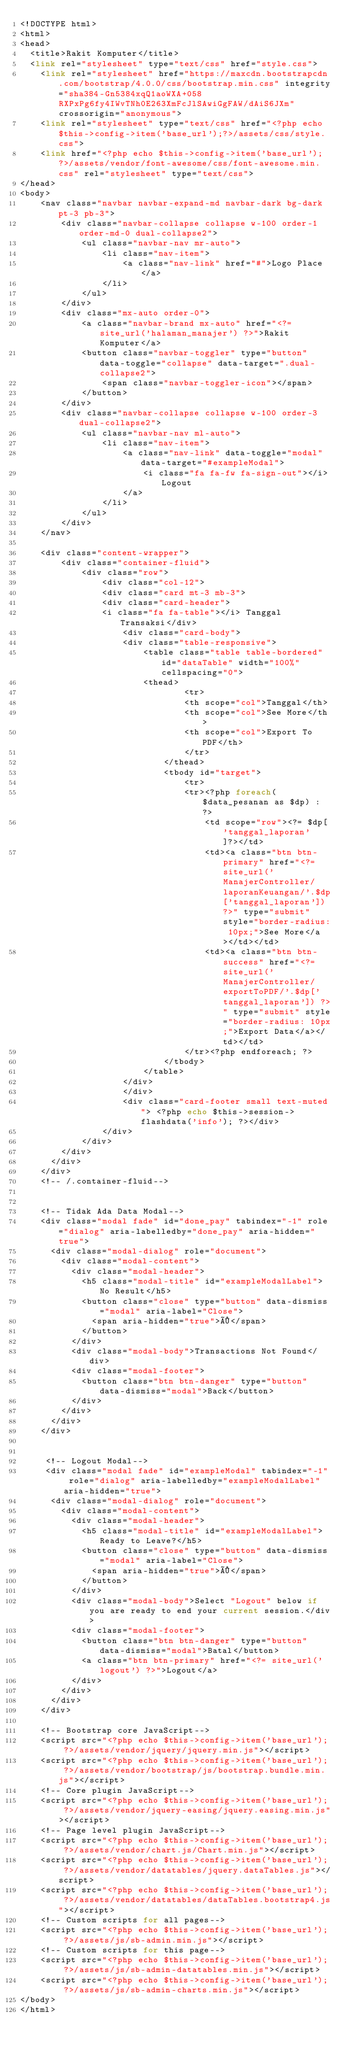<code> <loc_0><loc_0><loc_500><loc_500><_PHP_><!DOCTYPE html>
<html>
<head>
	<title>Rakit Komputer</title>
	<link rel="stylesheet" type="text/css" href="style.css">
    <link rel="stylesheet" href="https://maxcdn.bootstrapcdn.com/bootstrap/4.0.0/css/bootstrap.min.css" integrity="sha384-Gn5384xqQ1aoWXA+058RXPxPg6fy4IWvTNh0E263XmFcJlSAwiGgFAW/dAiS6JXm" crossorigin="anonymous">
    <link rel="stylesheet" type="text/css" href="<?php echo $this->config->item('base_url');?>/assets/css/style.css">
    <link href="<?php echo $this->config->item('base_url'); ?>/assets/vendor/font-awesome/css/font-awesome.min.css" rel="stylesheet" type="text/css">
</head>
<body>
    <nav class="navbar navbar-expand-md navbar-dark bg-dark pt-3 pb-3">
        <div class="navbar-collapse collapse w-100 order-1 order-md-0 dual-collapse2">
            <ul class="navbar-nav mr-auto">
                <li class="nav-item">    
                    <a class="nav-link" href="#">Logo Place </a>
                </li>
            </ul>
        </div>
        <div class="mx-auto order-0">
            <a class="navbar-brand mx-auto" href="<?= site_url('halaman_manajer') ?>">Rakit Komputer</a>
            <button class="navbar-toggler" type="button" data-toggle="collapse" data-target=".dual-collapse2">
                <span class="navbar-toggler-icon"></span>
            </button>
        </div>
        <div class="navbar-collapse collapse w-100 order-3 dual-collapse2">
            <ul class="navbar-nav ml-auto">
                <li class="nav-item">
                    <a class="nav-link" data-toggle="modal" data-target="#exampleModal">
                        <i class="fa fa-fw fa-sign-out"></i>Logout
                    </a>
                </li>
            </ul>
        </div>
    </nav>

    <div class="content-wrapper">
        <div class="container-fluid">
            <div class="row">
                <div class="col-12">
                <div class="card mt-3 mb-3">
                <div class="card-header">
                <i class="fa fa-table"></i> Tanggal Transaksi</div>
                    <div class="card-body">
                    <div class="table-responsive">
                        <table class="table table-bordered" id="dataTable" width="100%" cellspacing="0">
                        <thead>
                                <tr>
                                <th scope="col">Tanggal</th>
                                <th scope="col">See More</th>
                                <th scope="col">Export To PDF</th>
                                </tr>
                            </thead>
                            <tbody id="target">
                                <tr>
                                <tr><?php foreach($data_pesanan as $dp) : ?>
                                    <td scope="row"><?= $dp['tanggal_laporan']?></td>
                                    <td><a class="btn btn-primary" href="<?= site_url('ManajerController/laporanKeuangan/'.$dp['tanggal_laporan']) ?>" type="submit" style="border-radius: 10px;">See More</a></td></td>
                                    <td><a class="btn btn-success" href="<?= site_url('ManajerController/exportToPDF/'.$dp['tanggal_laporan']) ?>" type="submit" style="border-radius: 10px;">Export Data</a></td></td>
                                </tr><?php endforeach; ?>
                            </tbody>                   
                        </table>
                    </div>
                    </div>
                    <div class="card-footer small text-muted"> <?php echo $this->session->flashdata('info'); ?></div>
                </div>
            </div>
        </div>
      </div>
    </div>
    <!-- /.container-fluid-->


    <!-- Tidak Ada Data Modal-->
    <div class="modal fade" id="done_pay" tabindex="-1" role="dialog" aria-labelledby="done_pay" aria-hidden="true">
      <div class="modal-dialog" role="document">
        <div class="modal-content">
          <div class="modal-header">
            <h5 class="modal-title" id="exampleModalLabel">No Result</h5>
            <button class="close" type="button" data-dismiss="modal" aria-label="Close">
              <span aria-hidden="true">×</span>
            </button>
          </div>
          <div class="modal-body">Transactions Not Found</div>
          <div class="modal-footer">
            <button class="btn btn-danger" type="button" data-dismiss="modal">Back</button>
          </div>
        </div>
      </div>
    </div>


     <!-- Logout Modal-->
     <div class="modal fade" id="exampleModal" tabindex="-1" role="dialog" aria-labelledby="exampleModalLabel" aria-hidden="true">
      <div class="modal-dialog" role="document">
        <div class="modal-content">
          <div class="modal-header">
            <h5 class="modal-title" id="exampleModalLabel">Ready to Leave?</h5>
            <button class="close" type="button" data-dismiss="modal" aria-label="Close">
              <span aria-hidden="true">×</span>
            </button>
          </div>
          <div class="modal-body">Select "Logout" below if you are ready to end your current session.</div>
          <div class="modal-footer">
            <button class="btn btn-danger" type="button" data-dismiss="modal">Batal</button>
            <a class="btn btn-primary" href="<?= site_url('logout') ?>">Logout</a>
          </div>
        </div>
      </div>
    </div>

    <!-- Bootstrap core JavaScript-->
    <script src="<?php echo $this->config->item('base_url'); ?>/assets/vendor/jquery/jquery.min.js"></script>
    <script src="<?php echo $this->config->item('base_url'); ?>/assets/vendor/bootstrap/js/bootstrap.bundle.min.js"></script>
    <!-- Core plugin JavaScript-->
    <script src="<?php echo $this->config->item('base_url'); ?>/assets/vendor/jquery-easing/jquery.easing.min.js"></script>
    <!-- Page level plugin JavaScript-->
    <script src="<?php echo $this->config->item('base_url'); ?>/assets/vendor/chart.js/Chart.min.js"></script>
    <script src="<?php echo $this->config->item('base_url'); ?>/assets/vendor/datatables/jquery.dataTables.js"></script>
    <script src="<?php echo $this->config->item('base_url'); ?>/assets/vendor/datatables/dataTables.bootstrap4.js"></script>
    <!-- Custom scripts for all pages-->
    <script src="<?php echo $this->config->item('base_url'); ?>/assets/js/sb-admin.min.js"></script>
    <!-- Custom scripts for this page-->
    <script src="<?php echo $this->config->item('base_url'); ?>/assets/js/sb-admin-datatables.min.js"></script>
    <script src="<?php echo $this->config->item('base_url'); ?>/assets/js/sb-admin-charts.min.js"></script>
</body>
</html>
</code> 